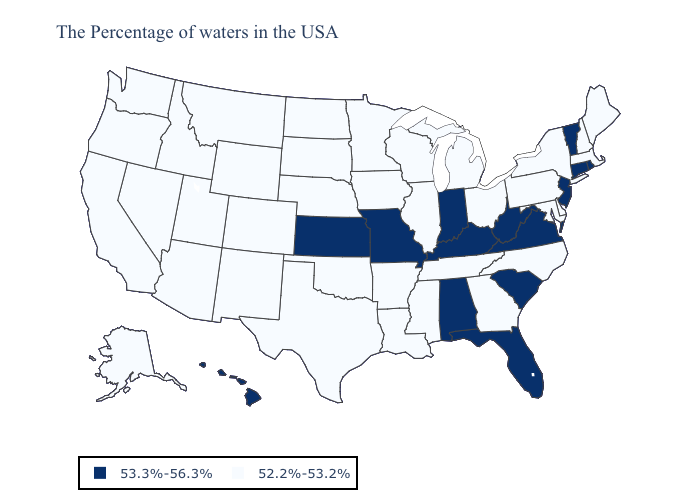Which states hav the highest value in the MidWest?
Quick response, please. Indiana, Missouri, Kansas. Does Missouri have the same value as Florida?
Be succinct. Yes. What is the lowest value in the MidWest?
Answer briefly. 52.2%-53.2%. Among the states that border Georgia , does Tennessee have the lowest value?
Short answer required. Yes. What is the highest value in the USA?
Write a very short answer. 53.3%-56.3%. What is the value of Missouri?
Answer briefly. 53.3%-56.3%. Which states hav the highest value in the Northeast?
Give a very brief answer. Rhode Island, Vermont, Connecticut, New Jersey. Is the legend a continuous bar?
Concise answer only. No. Does Nebraska have the lowest value in the USA?
Short answer required. Yes. Does Kansas have the lowest value in the MidWest?
Keep it brief. No. Name the states that have a value in the range 53.3%-56.3%?
Short answer required. Rhode Island, Vermont, Connecticut, New Jersey, Virginia, South Carolina, West Virginia, Florida, Kentucky, Indiana, Alabama, Missouri, Kansas, Hawaii. Among the states that border New Jersey , which have the highest value?
Short answer required. New York, Delaware, Pennsylvania. Among the states that border Oklahoma , does New Mexico have the highest value?
Keep it brief. No. Does Idaho have the highest value in the West?
Answer briefly. No. 